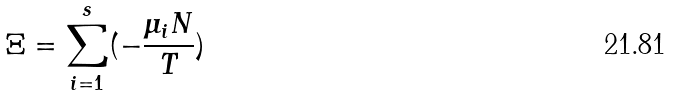<formula> <loc_0><loc_0><loc_500><loc_500>\Xi = \sum _ { i = 1 } ^ { s } ( - \frac { \mu _ { i } N } { T } )</formula> 